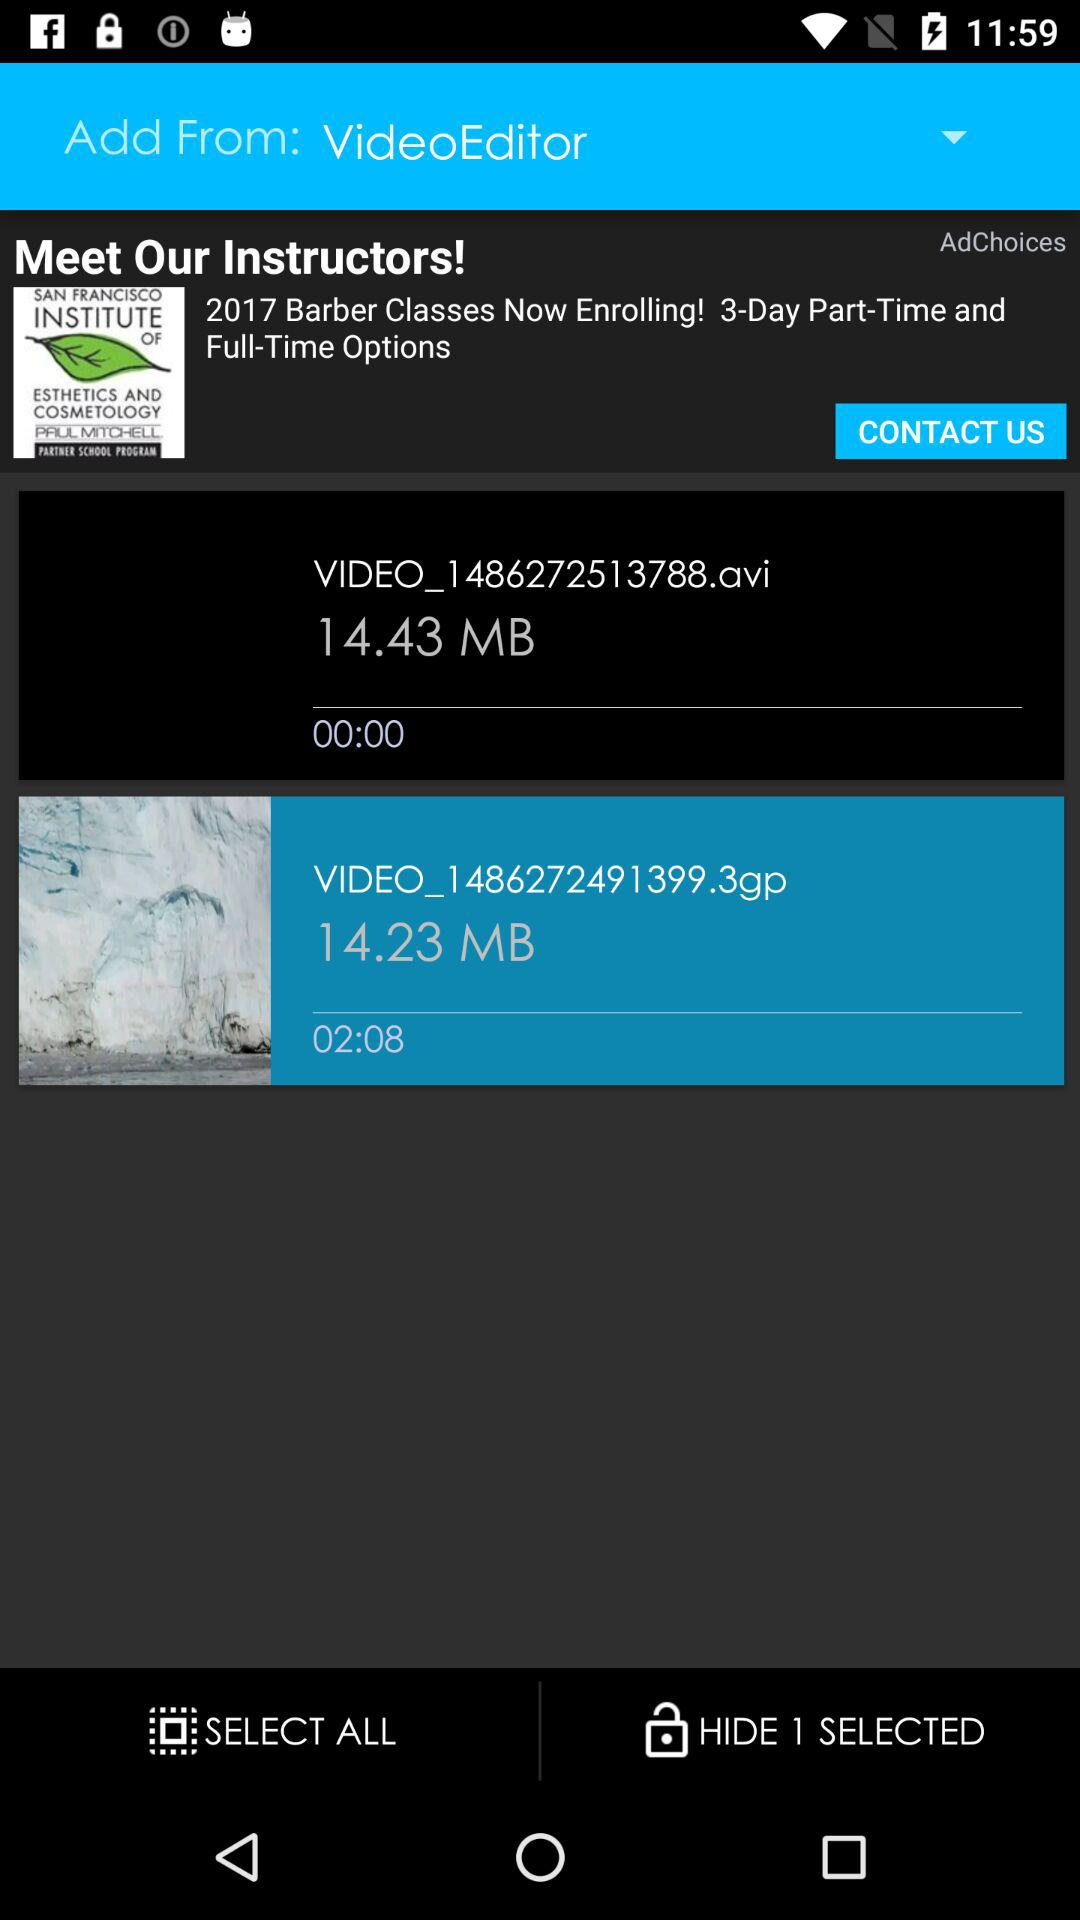How many videos are there?
Answer the question using a single word or phrase. 2 